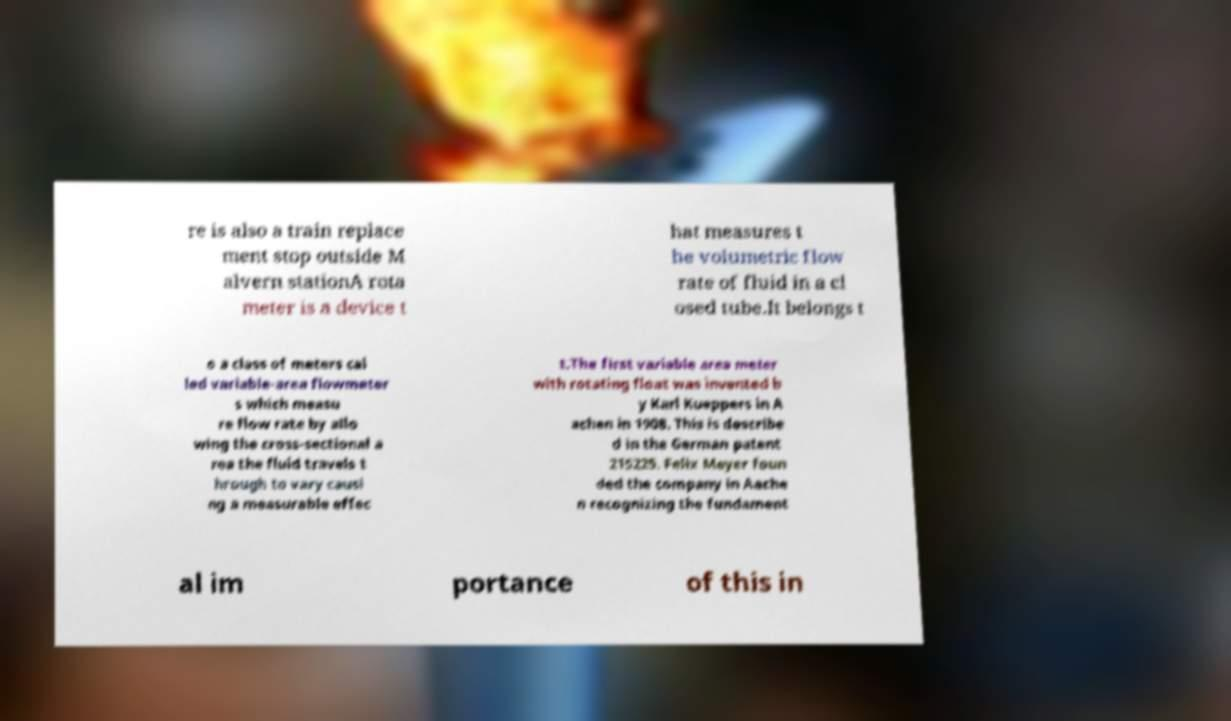There's text embedded in this image that I need extracted. Can you transcribe it verbatim? re is also a train replace ment stop outside M alvern stationA rota meter is a device t hat measures t he volumetric flow rate of fluid in a cl osed tube.It belongs t o a class of meters cal led variable-area flowmeter s which measu re flow rate by allo wing the cross-sectional a rea the fluid travels t hrough to vary causi ng a measurable effec t.The first variable area meter with rotating float was invented b y Karl Kueppers in A achen in 1908. This is describe d in the German patent 215225. Felix Meyer foun ded the company in Aache n recognizing the fundament al im portance of this in 